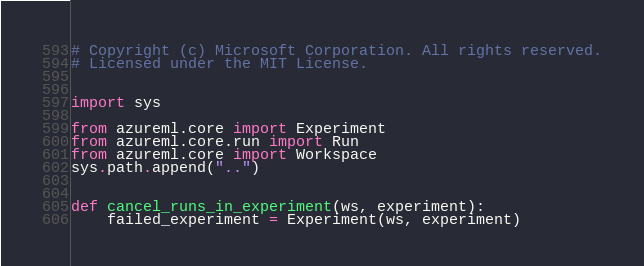<code> <loc_0><loc_0><loc_500><loc_500><_Python_># Copyright (c) Microsoft Corporation. All rights reserved.
# Licensed under the MIT License.


import sys

from azureml.core import Experiment
from azureml.core.run import Run
from azureml.core import Workspace
sys.path.append("..")


def cancel_runs_in_experiment(ws, experiment):
    failed_experiment = Experiment(ws, experiment)</code> 